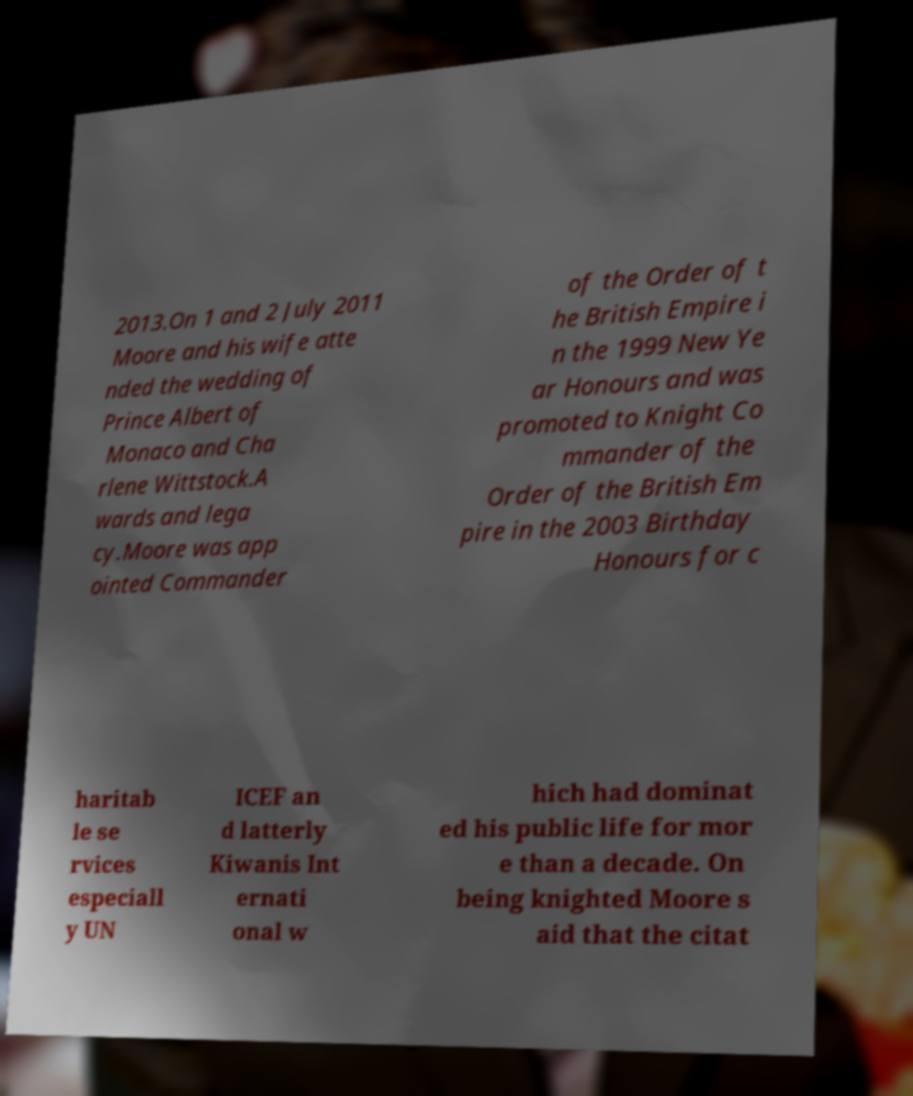Can you read and provide the text displayed in the image?This photo seems to have some interesting text. Can you extract and type it out for me? 2013.On 1 and 2 July 2011 Moore and his wife atte nded the wedding of Prince Albert of Monaco and Cha rlene Wittstock.A wards and lega cy.Moore was app ointed Commander of the Order of t he British Empire i n the 1999 New Ye ar Honours and was promoted to Knight Co mmander of the Order of the British Em pire in the 2003 Birthday Honours for c haritab le se rvices especiall y UN ICEF an d latterly Kiwanis Int ernati onal w hich had dominat ed his public life for mor e than a decade. On being knighted Moore s aid that the citat 